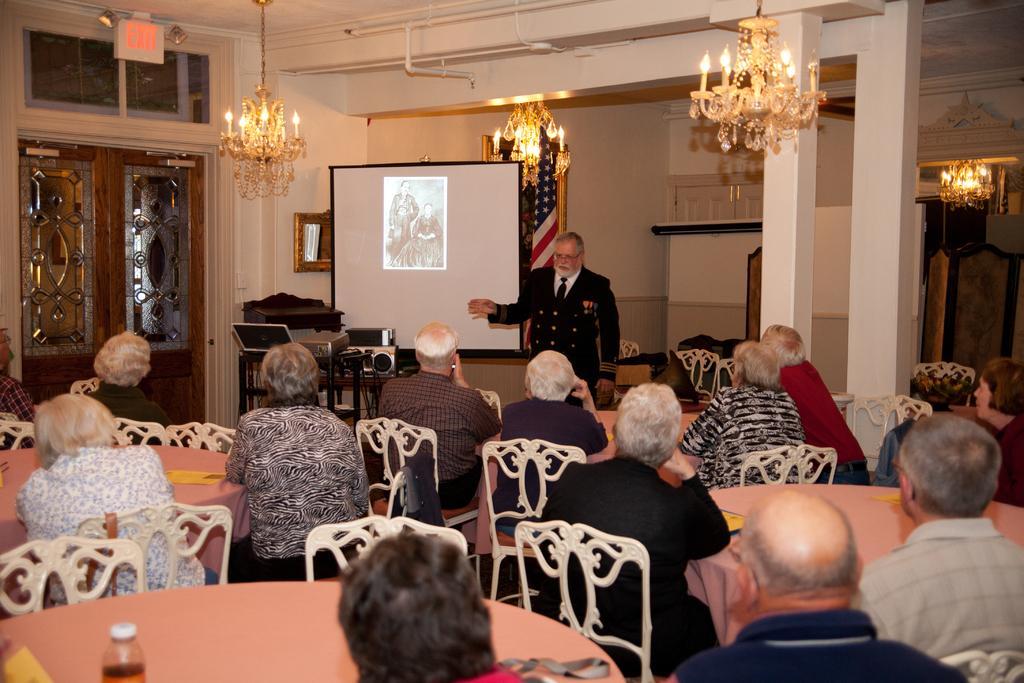How would you summarize this image in a sentence or two? As we can see in the image there is a white color wall, door, chandeliers and few people sitting on chairs and there is a table. On table there is a bottle and there is a screen over here. 